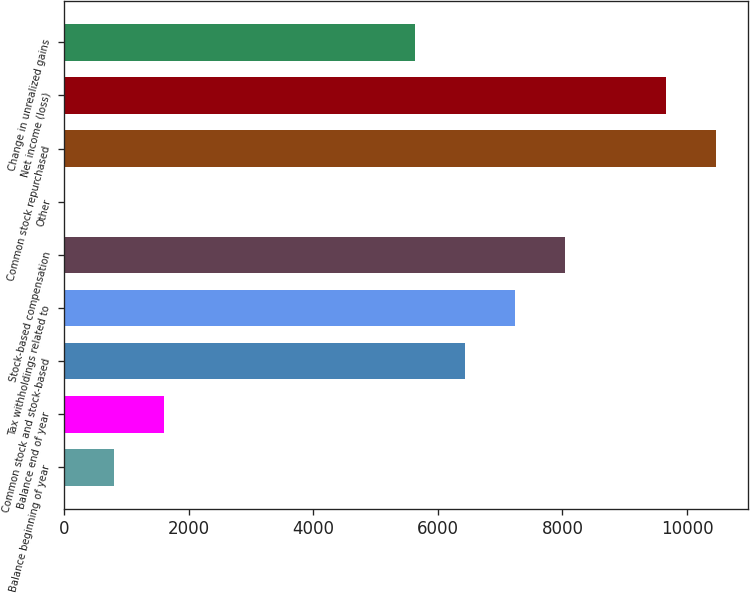Convert chart. <chart><loc_0><loc_0><loc_500><loc_500><bar_chart><fcel>Balance beginning of year<fcel>Balance end of year<fcel>Common stock and stock-based<fcel>Tax withholdings related to<fcel>Stock-based compensation<fcel>Other<fcel>Common stock repurchased<fcel>Net income (loss)<fcel>Change in unrealized gains<nl><fcel>805.8<fcel>1610.6<fcel>6439.4<fcel>7244.2<fcel>8049<fcel>1<fcel>10463.4<fcel>9658.6<fcel>5634.6<nl></chart> 